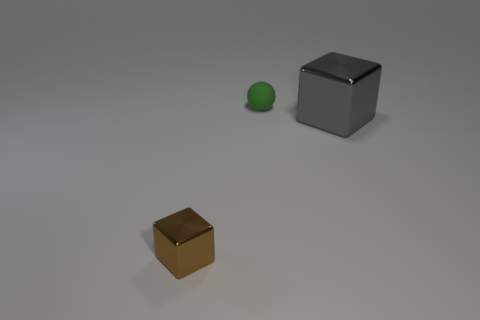Does the tiny ball have the same color as the big block?
Offer a very short reply. No. There is a large gray thing that is the same shape as the brown metallic object; what is it made of?
Make the answer very short. Metal. What shape is the metallic thing in front of the block on the right side of the small green object that is behind the gray block?
Keep it short and to the point. Cube. There is a thing that is both on the right side of the brown metal cube and on the left side of the large gray metal block; what is it made of?
Your answer should be compact. Rubber. Is the size of the thing that is left of the rubber sphere the same as the small green rubber sphere?
Ensure brevity in your answer.  Yes. Is there any other thing that is the same size as the gray metallic block?
Offer a very short reply. No. Is the number of cubes behind the tiny shiny object greater than the number of small shiny blocks to the right of the tiny green object?
Your answer should be very brief. Yes. There is a thing that is right of the tiny object behind the metallic thing that is behind the brown thing; what is its color?
Keep it short and to the point. Gray. How many other things are the same color as the tiny metal thing?
Provide a succinct answer. 0. What number of objects are green matte balls or tiny gray metallic blocks?
Offer a terse response. 1. 